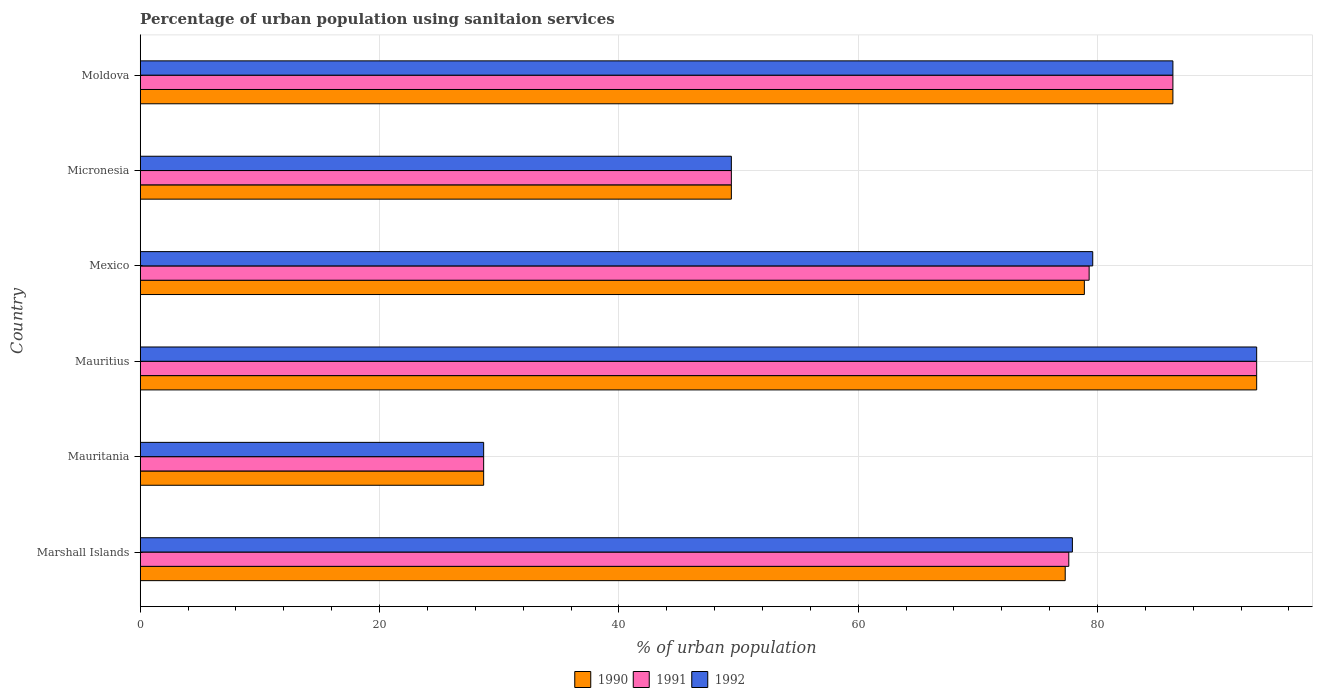How many different coloured bars are there?
Keep it short and to the point. 3. How many groups of bars are there?
Make the answer very short. 6. Are the number of bars per tick equal to the number of legend labels?
Make the answer very short. Yes. Are the number of bars on each tick of the Y-axis equal?
Your answer should be very brief. Yes. How many bars are there on the 2nd tick from the bottom?
Provide a succinct answer. 3. What is the label of the 4th group of bars from the top?
Provide a short and direct response. Mauritius. What is the percentage of urban population using sanitaion services in 1991 in Mauritania?
Keep it short and to the point. 28.7. Across all countries, what is the maximum percentage of urban population using sanitaion services in 1992?
Your answer should be very brief. 93.3. Across all countries, what is the minimum percentage of urban population using sanitaion services in 1991?
Your answer should be very brief. 28.7. In which country was the percentage of urban population using sanitaion services in 1992 maximum?
Offer a terse response. Mauritius. In which country was the percentage of urban population using sanitaion services in 1990 minimum?
Give a very brief answer. Mauritania. What is the total percentage of urban population using sanitaion services in 1992 in the graph?
Ensure brevity in your answer.  415.2. What is the difference between the percentage of urban population using sanitaion services in 1992 in Mexico and that in Moldova?
Make the answer very short. -6.7. What is the difference between the percentage of urban population using sanitaion services in 1990 in Mauritius and the percentage of urban population using sanitaion services in 1991 in Micronesia?
Keep it short and to the point. 43.9. What is the average percentage of urban population using sanitaion services in 1991 per country?
Provide a succinct answer. 69.1. What is the difference between the percentage of urban population using sanitaion services in 1992 and percentage of urban population using sanitaion services in 1990 in Mexico?
Provide a short and direct response. 0.7. What is the ratio of the percentage of urban population using sanitaion services in 1990 in Mauritius to that in Moldova?
Your answer should be compact. 1.08. Is the percentage of urban population using sanitaion services in 1991 in Marshall Islands less than that in Moldova?
Offer a terse response. Yes. Is the difference between the percentage of urban population using sanitaion services in 1992 in Marshall Islands and Mexico greater than the difference between the percentage of urban population using sanitaion services in 1990 in Marshall Islands and Mexico?
Your response must be concise. No. What is the difference between the highest and the second highest percentage of urban population using sanitaion services in 1992?
Provide a short and direct response. 7. What is the difference between the highest and the lowest percentage of urban population using sanitaion services in 1991?
Give a very brief answer. 64.6. In how many countries, is the percentage of urban population using sanitaion services in 1991 greater than the average percentage of urban population using sanitaion services in 1991 taken over all countries?
Provide a succinct answer. 4. Is the sum of the percentage of urban population using sanitaion services in 1992 in Marshall Islands and Micronesia greater than the maximum percentage of urban population using sanitaion services in 1990 across all countries?
Offer a very short reply. Yes. What does the 3rd bar from the top in Mauritania represents?
Your answer should be very brief. 1990. What does the 1st bar from the bottom in Marshall Islands represents?
Ensure brevity in your answer.  1990. How many bars are there?
Provide a succinct answer. 18. Are all the bars in the graph horizontal?
Offer a very short reply. Yes. How many countries are there in the graph?
Your response must be concise. 6. Does the graph contain grids?
Your answer should be very brief. Yes. Where does the legend appear in the graph?
Offer a terse response. Bottom center. What is the title of the graph?
Ensure brevity in your answer.  Percentage of urban population using sanitaion services. Does "1981" appear as one of the legend labels in the graph?
Keep it short and to the point. No. What is the label or title of the X-axis?
Provide a short and direct response. % of urban population. What is the % of urban population of 1990 in Marshall Islands?
Give a very brief answer. 77.3. What is the % of urban population of 1991 in Marshall Islands?
Offer a very short reply. 77.6. What is the % of urban population of 1992 in Marshall Islands?
Your answer should be compact. 77.9. What is the % of urban population of 1990 in Mauritania?
Ensure brevity in your answer.  28.7. What is the % of urban population in 1991 in Mauritania?
Offer a very short reply. 28.7. What is the % of urban population in 1992 in Mauritania?
Provide a succinct answer. 28.7. What is the % of urban population of 1990 in Mauritius?
Your answer should be very brief. 93.3. What is the % of urban population in 1991 in Mauritius?
Offer a very short reply. 93.3. What is the % of urban population in 1992 in Mauritius?
Keep it short and to the point. 93.3. What is the % of urban population of 1990 in Mexico?
Keep it short and to the point. 78.9. What is the % of urban population of 1991 in Mexico?
Offer a terse response. 79.3. What is the % of urban population of 1992 in Mexico?
Give a very brief answer. 79.6. What is the % of urban population in 1990 in Micronesia?
Keep it short and to the point. 49.4. What is the % of urban population of 1991 in Micronesia?
Ensure brevity in your answer.  49.4. What is the % of urban population of 1992 in Micronesia?
Your answer should be compact. 49.4. What is the % of urban population of 1990 in Moldova?
Offer a very short reply. 86.3. What is the % of urban population in 1991 in Moldova?
Provide a short and direct response. 86.3. What is the % of urban population in 1992 in Moldova?
Offer a terse response. 86.3. Across all countries, what is the maximum % of urban population of 1990?
Offer a very short reply. 93.3. Across all countries, what is the maximum % of urban population in 1991?
Give a very brief answer. 93.3. Across all countries, what is the maximum % of urban population of 1992?
Make the answer very short. 93.3. Across all countries, what is the minimum % of urban population of 1990?
Offer a very short reply. 28.7. Across all countries, what is the minimum % of urban population in 1991?
Your answer should be compact. 28.7. Across all countries, what is the minimum % of urban population in 1992?
Your answer should be compact. 28.7. What is the total % of urban population in 1990 in the graph?
Give a very brief answer. 413.9. What is the total % of urban population in 1991 in the graph?
Offer a terse response. 414.6. What is the total % of urban population in 1992 in the graph?
Keep it short and to the point. 415.2. What is the difference between the % of urban population of 1990 in Marshall Islands and that in Mauritania?
Offer a very short reply. 48.6. What is the difference between the % of urban population of 1991 in Marshall Islands and that in Mauritania?
Ensure brevity in your answer.  48.9. What is the difference between the % of urban population in 1992 in Marshall Islands and that in Mauritania?
Keep it short and to the point. 49.2. What is the difference between the % of urban population of 1991 in Marshall Islands and that in Mauritius?
Offer a terse response. -15.7. What is the difference between the % of urban population in 1992 in Marshall Islands and that in Mauritius?
Offer a very short reply. -15.4. What is the difference between the % of urban population in 1991 in Marshall Islands and that in Mexico?
Offer a very short reply. -1.7. What is the difference between the % of urban population of 1990 in Marshall Islands and that in Micronesia?
Provide a succinct answer. 27.9. What is the difference between the % of urban population of 1991 in Marshall Islands and that in Micronesia?
Your answer should be very brief. 28.2. What is the difference between the % of urban population of 1992 in Marshall Islands and that in Micronesia?
Your answer should be compact. 28.5. What is the difference between the % of urban population in 1990 in Mauritania and that in Mauritius?
Your answer should be very brief. -64.6. What is the difference between the % of urban population in 1991 in Mauritania and that in Mauritius?
Offer a very short reply. -64.6. What is the difference between the % of urban population in 1992 in Mauritania and that in Mauritius?
Provide a short and direct response. -64.6. What is the difference between the % of urban population of 1990 in Mauritania and that in Mexico?
Make the answer very short. -50.2. What is the difference between the % of urban population of 1991 in Mauritania and that in Mexico?
Provide a succinct answer. -50.6. What is the difference between the % of urban population in 1992 in Mauritania and that in Mexico?
Make the answer very short. -50.9. What is the difference between the % of urban population in 1990 in Mauritania and that in Micronesia?
Provide a succinct answer. -20.7. What is the difference between the % of urban population of 1991 in Mauritania and that in Micronesia?
Provide a succinct answer. -20.7. What is the difference between the % of urban population in 1992 in Mauritania and that in Micronesia?
Your answer should be compact. -20.7. What is the difference between the % of urban population in 1990 in Mauritania and that in Moldova?
Offer a very short reply. -57.6. What is the difference between the % of urban population in 1991 in Mauritania and that in Moldova?
Give a very brief answer. -57.6. What is the difference between the % of urban population in 1992 in Mauritania and that in Moldova?
Offer a very short reply. -57.6. What is the difference between the % of urban population in 1990 in Mauritius and that in Mexico?
Offer a terse response. 14.4. What is the difference between the % of urban population in 1990 in Mauritius and that in Micronesia?
Your answer should be compact. 43.9. What is the difference between the % of urban population in 1991 in Mauritius and that in Micronesia?
Make the answer very short. 43.9. What is the difference between the % of urban population in 1992 in Mauritius and that in Micronesia?
Your answer should be very brief. 43.9. What is the difference between the % of urban population in 1990 in Mauritius and that in Moldova?
Your response must be concise. 7. What is the difference between the % of urban population of 1991 in Mauritius and that in Moldova?
Offer a very short reply. 7. What is the difference between the % of urban population in 1990 in Mexico and that in Micronesia?
Your response must be concise. 29.5. What is the difference between the % of urban population in 1991 in Mexico and that in Micronesia?
Keep it short and to the point. 29.9. What is the difference between the % of urban population of 1992 in Mexico and that in Micronesia?
Provide a succinct answer. 30.2. What is the difference between the % of urban population of 1990 in Mexico and that in Moldova?
Provide a succinct answer. -7.4. What is the difference between the % of urban population of 1991 in Mexico and that in Moldova?
Give a very brief answer. -7. What is the difference between the % of urban population in 1992 in Mexico and that in Moldova?
Keep it short and to the point. -6.7. What is the difference between the % of urban population of 1990 in Micronesia and that in Moldova?
Give a very brief answer. -36.9. What is the difference between the % of urban population of 1991 in Micronesia and that in Moldova?
Your answer should be very brief. -36.9. What is the difference between the % of urban population of 1992 in Micronesia and that in Moldova?
Offer a very short reply. -36.9. What is the difference between the % of urban population of 1990 in Marshall Islands and the % of urban population of 1991 in Mauritania?
Your response must be concise. 48.6. What is the difference between the % of urban population in 1990 in Marshall Islands and the % of urban population in 1992 in Mauritania?
Ensure brevity in your answer.  48.6. What is the difference between the % of urban population in 1991 in Marshall Islands and the % of urban population in 1992 in Mauritania?
Give a very brief answer. 48.9. What is the difference between the % of urban population of 1991 in Marshall Islands and the % of urban population of 1992 in Mauritius?
Offer a terse response. -15.7. What is the difference between the % of urban population in 1990 in Marshall Islands and the % of urban population in 1991 in Mexico?
Make the answer very short. -2. What is the difference between the % of urban population in 1990 in Marshall Islands and the % of urban population in 1991 in Micronesia?
Your response must be concise. 27.9. What is the difference between the % of urban population of 1990 in Marshall Islands and the % of urban population of 1992 in Micronesia?
Offer a terse response. 27.9. What is the difference between the % of urban population of 1991 in Marshall Islands and the % of urban population of 1992 in Micronesia?
Provide a short and direct response. 28.2. What is the difference between the % of urban population of 1990 in Marshall Islands and the % of urban population of 1991 in Moldova?
Provide a succinct answer. -9. What is the difference between the % of urban population in 1991 in Marshall Islands and the % of urban population in 1992 in Moldova?
Offer a very short reply. -8.7. What is the difference between the % of urban population of 1990 in Mauritania and the % of urban population of 1991 in Mauritius?
Your answer should be compact. -64.6. What is the difference between the % of urban population in 1990 in Mauritania and the % of urban population in 1992 in Mauritius?
Offer a very short reply. -64.6. What is the difference between the % of urban population of 1991 in Mauritania and the % of urban population of 1992 in Mauritius?
Provide a short and direct response. -64.6. What is the difference between the % of urban population in 1990 in Mauritania and the % of urban population in 1991 in Mexico?
Make the answer very short. -50.6. What is the difference between the % of urban population in 1990 in Mauritania and the % of urban population in 1992 in Mexico?
Keep it short and to the point. -50.9. What is the difference between the % of urban population in 1991 in Mauritania and the % of urban population in 1992 in Mexico?
Your answer should be compact. -50.9. What is the difference between the % of urban population of 1990 in Mauritania and the % of urban population of 1991 in Micronesia?
Your answer should be compact. -20.7. What is the difference between the % of urban population of 1990 in Mauritania and the % of urban population of 1992 in Micronesia?
Your response must be concise. -20.7. What is the difference between the % of urban population of 1991 in Mauritania and the % of urban population of 1992 in Micronesia?
Make the answer very short. -20.7. What is the difference between the % of urban population of 1990 in Mauritania and the % of urban population of 1991 in Moldova?
Keep it short and to the point. -57.6. What is the difference between the % of urban population in 1990 in Mauritania and the % of urban population in 1992 in Moldova?
Ensure brevity in your answer.  -57.6. What is the difference between the % of urban population of 1991 in Mauritania and the % of urban population of 1992 in Moldova?
Offer a very short reply. -57.6. What is the difference between the % of urban population in 1990 in Mauritius and the % of urban population in 1992 in Mexico?
Make the answer very short. 13.7. What is the difference between the % of urban population of 1991 in Mauritius and the % of urban population of 1992 in Mexico?
Keep it short and to the point. 13.7. What is the difference between the % of urban population of 1990 in Mauritius and the % of urban population of 1991 in Micronesia?
Your response must be concise. 43.9. What is the difference between the % of urban population of 1990 in Mauritius and the % of urban population of 1992 in Micronesia?
Your response must be concise. 43.9. What is the difference between the % of urban population in 1991 in Mauritius and the % of urban population in 1992 in Micronesia?
Ensure brevity in your answer.  43.9. What is the difference between the % of urban population in 1991 in Mauritius and the % of urban population in 1992 in Moldova?
Provide a succinct answer. 7. What is the difference between the % of urban population in 1990 in Mexico and the % of urban population in 1991 in Micronesia?
Your response must be concise. 29.5. What is the difference between the % of urban population in 1990 in Mexico and the % of urban population in 1992 in Micronesia?
Your response must be concise. 29.5. What is the difference between the % of urban population of 1991 in Mexico and the % of urban population of 1992 in Micronesia?
Offer a terse response. 29.9. What is the difference between the % of urban population of 1991 in Mexico and the % of urban population of 1992 in Moldova?
Give a very brief answer. -7. What is the difference between the % of urban population of 1990 in Micronesia and the % of urban population of 1991 in Moldova?
Make the answer very short. -36.9. What is the difference between the % of urban population of 1990 in Micronesia and the % of urban population of 1992 in Moldova?
Provide a succinct answer. -36.9. What is the difference between the % of urban population of 1991 in Micronesia and the % of urban population of 1992 in Moldova?
Offer a terse response. -36.9. What is the average % of urban population in 1990 per country?
Give a very brief answer. 68.98. What is the average % of urban population of 1991 per country?
Ensure brevity in your answer.  69.1. What is the average % of urban population of 1992 per country?
Ensure brevity in your answer.  69.2. What is the difference between the % of urban population of 1990 and % of urban population of 1992 in Marshall Islands?
Make the answer very short. -0.6. What is the difference between the % of urban population of 1991 and % of urban population of 1992 in Marshall Islands?
Your answer should be very brief. -0.3. What is the difference between the % of urban population in 1990 and % of urban population in 1991 in Mauritania?
Make the answer very short. 0. What is the difference between the % of urban population of 1990 and % of urban population of 1992 in Mauritania?
Provide a short and direct response. 0. What is the difference between the % of urban population of 1990 and % of urban population of 1992 in Mauritius?
Provide a succinct answer. 0. What is the difference between the % of urban population of 1991 and % of urban population of 1992 in Mauritius?
Ensure brevity in your answer.  0. What is the difference between the % of urban population of 1991 and % of urban population of 1992 in Mexico?
Provide a short and direct response. -0.3. What is the difference between the % of urban population of 1990 and % of urban population of 1992 in Micronesia?
Offer a terse response. 0. What is the difference between the % of urban population in 1990 and % of urban population in 1991 in Moldova?
Ensure brevity in your answer.  0. What is the difference between the % of urban population in 1990 and % of urban population in 1992 in Moldova?
Make the answer very short. 0. What is the difference between the % of urban population in 1991 and % of urban population in 1992 in Moldova?
Make the answer very short. 0. What is the ratio of the % of urban population in 1990 in Marshall Islands to that in Mauritania?
Your answer should be very brief. 2.69. What is the ratio of the % of urban population of 1991 in Marshall Islands to that in Mauritania?
Your response must be concise. 2.7. What is the ratio of the % of urban population in 1992 in Marshall Islands to that in Mauritania?
Provide a short and direct response. 2.71. What is the ratio of the % of urban population of 1990 in Marshall Islands to that in Mauritius?
Your answer should be compact. 0.83. What is the ratio of the % of urban population in 1991 in Marshall Islands to that in Mauritius?
Offer a very short reply. 0.83. What is the ratio of the % of urban population in 1992 in Marshall Islands to that in Mauritius?
Offer a very short reply. 0.83. What is the ratio of the % of urban population in 1990 in Marshall Islands to that in Mexico?
Your answer should be compact. 0.98. What is the ratio of the % of urban population in 1991 in Marshall Islands to that in Mexico?
Give a very brief answer. 0.98. What is the ratio of the % of urban population of 1992 in Marshall Islands to that in Mexico?
Offer a very short reply. 0.98. What is the ratio of the % of urban population in 1990 in Marshall Islands to that in Micronesia?
Make the answer very short. 1.56. What is the ratio of the % of urban population of 1991 in Marshall Islands to that in Micronesia?
Offer a very short reply. 1.57. What is the ratio of the % of urban population of 1992 in Marshall Islands to that in Micronesia?
Your answer should be very brief. 1.58. What is the ratio of the % of urban population of 1990 in Marshall Islands to that in Moldova?
Offer a terse response. 0.9. What is the ratio of the % of urban population of 1991 in Marshall Islands to that in Moldova?
Your answer should be very brief. 0.9. What is the ratio of the % of urban population of 1992 in Marshall Islands to that in Moldova?
Offer a very short reply. 0.9. What is the ratio of the % of urban population of 1990 in Mauritania to that in Mauritius?
Provide a short and direct response. 0.31. What is the ratio of the % of urban population in 1991 in Mauritania to that in Mauritius?
Offer a very short reply. 0.31. What is the ratio of the % of urban population of 1992 in Mauritania to that in Mauritius?
Make the answer very short. 0.31. What is the ratio of the % of urban population of 1990 in Mauritania to that in Mexico?
Offer a terse response. 0.36. What is the ratio of the % of urban population in 1991 in Mauritania to that in Mexico?
Make the answer very short. 0.36. What is the ratio of the % of urban population of 1992 in Mauritania to that in Mexico?
Give a very brief answer. 0.36. What is the ratio of the % of urban population in 1990 in Mauritania to that in Micronesia?
Give a very brief answer. 0.58. What is the ratio of the % of urban population of 1991 in Mauritania to that in Micronesia?
Keep it short and to the point. 0.58. What is the ratio of the % of urban population of 1992 in Mauritania to that in Micronesia?
Keep it short and to the point. 0.58. What is the ratio of the % of urban population in 1990 in Mauritania to that in Moldova?
Your answer should be compact. 0.33. What is the ratio of the % of urban population in 1991 in Mauritania to that in Moldova?
Offer a terse response. 0.33. What is the ratio of the % of urban population in 1992 in Mauritania to that in Moldova?
Offer a terse response. 0.33. What is the ratio of the % of urban population in 1990 in Mauritius to that in Mexico?
Provide a succinct answer. 1.18. What is the ratio of the % of urban population in 1991 in Mauritius to that in Mexico?
Ensure brevity in your answer.  1.18. What is the ratio of the % of urban population of 1992 in Mauritius to that in Mexico?
Your answer should be very brief. 1.17. What is the ratio of the % of urban population of 1990 in Mauritius to that in Micronesia?
Your answer should be compact. 1.89. What is the ratio of the % of urban population of 1991 in Mauritius to that in Micronesia?
Ensure brevity in your answer.  1.89. What is the ratio of the % of urban population in 1992 in Mauritius to that in Micronesia?
Make the answer very short. 1.89. What is the ratio of the % of urban population of 1990 in Mauritius to that in Moldova?
Offer a very short reply. 1.08. What is the ratio of the % of urban population in 1991 in Mauritius to that in Moldova?
Make the answer very short. 1.08. What is the ratio of the % of urban population of 1992 in Mauritius to that in Moldova?
Make the answer very short. 1.08. What is the ratio of the % of urban population of 1990 in Mexico to that in Micronesia?
Offer a very short reply. 1.6. What is the ratio of the % of urban population in 1991 in Mexico to that in Micronesia?
Offer a very short reply. 1.61. What is the ratio of the % of urban population in 1992 in Mexico to that in Micronesia?
Your response must be concise. 1.61. What is the ratio of the % of urban population in 1990 in Mexico to that in Moldova?
Offer a terse response. 0.91. What is the ratio of the % of urban population in 1991 in Mexico to that in Moldova?
Your answer should be compact. 0.92. What is the ratio of the % of urban population of 1992 in Mexico to that in Moldova?
Keep it short and to the point. 0.92. What is the ratio of the % of urban population of 1990 in Micronesia to that in Moldova?
Ensure brevity in your answer.  0.57. What is the ratio of the % of urban population in 1991 in Micronesia to that in Moldova?
Make the answer very short. 0.57. What is the ratio of the % of urban population in 1992 in Micronesia to that in Moldova?
Give a very brief answer. 0.57. What is the difference between the highest and the second highest % of urban population of 1991?
Your response must be concise. 7. What is the difference between the highest and the second highest % of urban population in 1992?
Offer a very short reply. 7. What is the difference between the highest and the lowest % of urban population in 1990?
Ensure brevity in your answer.  64.6. What is the difference between the highest and the lowest % of urban population of 1991?
Give a very brief answer. 64.6. What is the difference between the highest and the lowest % of urban population in 1992?
Your answer should be compact. 64.6. 